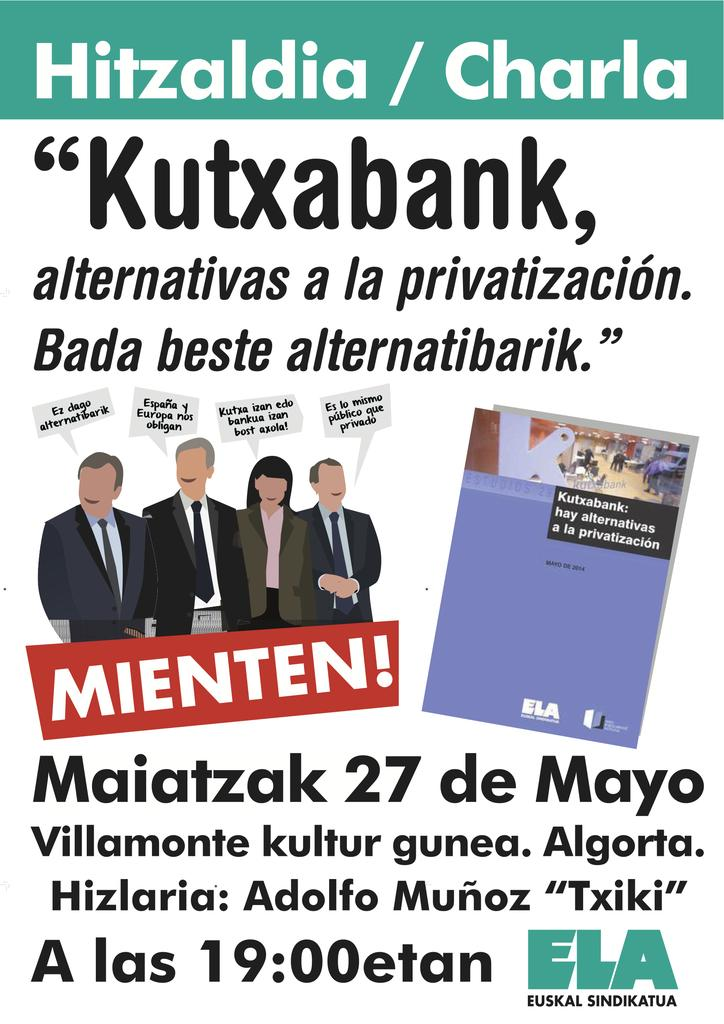What is featured in the image? There is a poster in the image. What can be seen on the poster? The poster contains animated pictures of people. What are the people in the animated pictures wearing? The people in the animated pictures are wearing clothes. Is there any text on the poster? Yes, there is text on the poster. What color is the orange in the image? There is no orange present in the image; it features a poster with animated pictures of people. What is the chance of winning a prize in the image? There is no mention of a prize or a chance to win in the image, as it only contains a poster with animated pictures of people. 